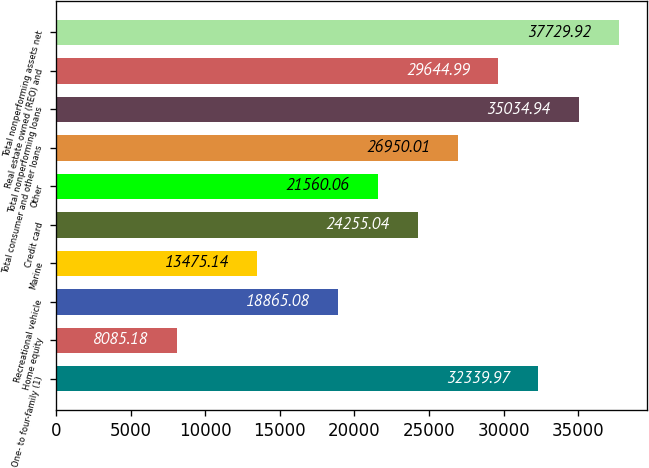<chart> <loc_0><loc_0><loc_500><loc_500><bar_chart><fcel>One- to four-family (1)<fcel>Home equity<fcel>Recreational vehicle<fcel>Marine<fcel>Credit card<fcel>Other<fcel>Total consumer and other loans<fcel>Total nonperforming loans<fcel>Real estate owned (REO) and<fcel>Total nonperforming assets net<nl><fcel>32340<fcel>8085.18<fcel>18865.1<fcel>13475.1<fcel>24255<fcel>21560.1<fcel>26950<fcel>35034.9<fcel>29645<fcel>37729.9<nl></chart> 